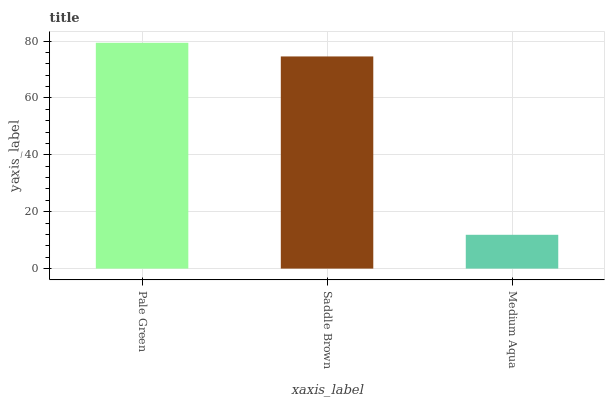Is Saddle Brown the minimum?
Answer yes or no. No. Is Saddle Brown the maximum?
Answer yes or no. No. Is Pale Green greater than Saddle Brown?
Answer yes or no. Yes. Is Saddle Brown less than Pale Green?
Answer yes or no. Yes. Is Saddle Brown greater than Pale Green?
Answer yes or no. No. Is Pale Green less than Saddle Brown?
Answer yes or no. No. Is Saddle Brown the high median?
Answer yes or no. Yes. Is Saddle Brown the low median?
Answer yes or no. Yes. Is Medium Aqua the high median?
Answer yes or no. No. Is Medium Aqua the low median?
Answer yes or no. No. 